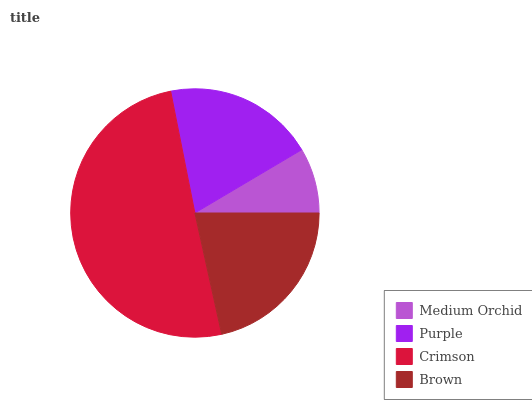Is Medium Orchid the minimum?
Answer yes or no. Yes. Is Crimson the maximum?
Answer yes or no. Yes. Is Purple the minimum?
Answer yes or no. No. Is Purple the maximum?
Answer yes or no. No. Is Purple greater than Medium Orchid?
Answer yes or no. Yes. Is Medium Orchid less than Purple?
Answer yes or no. Yes. Is Medium Orchid greater than Purple?
Answer yes or no. No. Is Purple less than Medium Orchid?
Answer yes or no. No. Is Brown the high median?
Answer yes or no. Yes. Is Purple the low median?
Answer yes or no. Yes. Is Medium Orchid the high median?
Answer yes or no. No. Is Medium Orchid the low median?
Answer yes or no. No. 